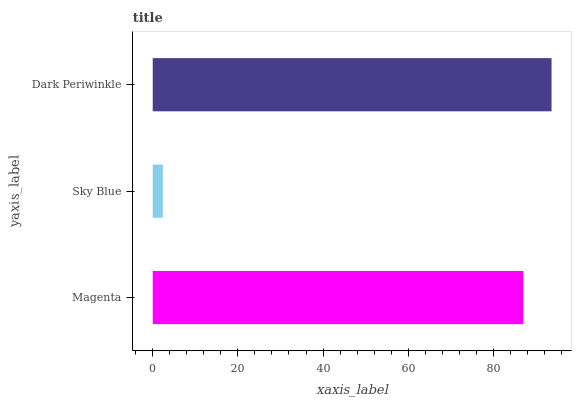Is Sky Blue the minimum?
Answer yes or no. Yes. Is Dark Periwinkle the maximum?
Answer yes or no. Yes. Is Dark Periwinkle the minimum?
Answer yes or no. No. Is Sky Blue the maximum?
Answer yes or no. No. Is Dark Periwinkle greater than Sky Blue?
Answer yes or no. Yes. Is Sky Blue less than Dark Periwinkle?
Answer yes or no. Yes. Is Sky Blue greater than Dark Periwinkle?
Answer yes or no. No. Is Dark Periwinkle less than Sky Blue?
Answer yes or no. No. Is Magenta the high median?
Answer yes or no. Yes. Is Magenta the low median?
Answer yes or no. Yes. Is Dark Periwinkle the high median?
Answer yes or no. No. Is Dark Periwinkle the low median?
Answer yes or no. No. 